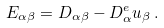<formula> <loc_0><loc_0><loc_500><loc_500>E _ { \alpha \beta } = D _ { \alpha \beta } - { D } ^ { e } _ { \alpha } { u } _ { \beta } \, .</formula> 